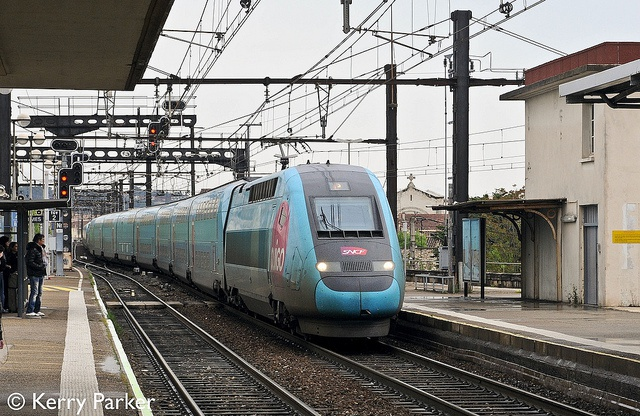Describe the objects in this image and their specific colors. I can see train in black, gray, and darkgray tones, people in black, gray, and darkgray tones, people in black and gray tones, traffic light in black, gray, darkgray, and lightgray tones, and people in black and gray tones in this image. 